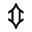<formula> <loc_0><loc_0><loc_500><loc_500>\Updownarrow</formula> 